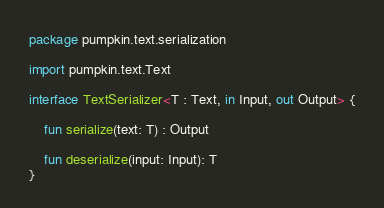Convert code to text. <code><loc_0><loc_0><loc_500><loc_500><_Kotlin_>package pumpkin.text.serialization

import pumpkin.text.Text

interface TextSerializer<T : Text, in Input, out Output> {

    fun serialize(text: T) : Output

    fun deserialize(input: Input): T
}</code> 